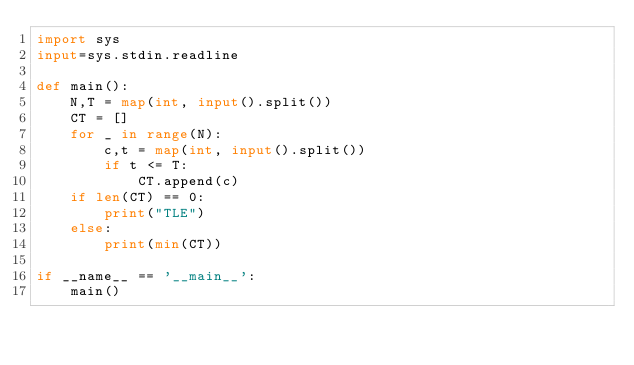Convert code to text. <code><loc_0><loc_0><loc_500><loc_500><_Python_>import sys
input=sys.stdin.readline

def main():
    N,T = map(int, input().split())
    CT = []
    for _ in range(N):
        c,t = map(int, input().split())
        if t <= T:
            CT.append(c)
    if len(CT) == 0:
        print("TLE")
    else:
        print(min(CT))

if __name__ == '__main__':
    main()
</code> 